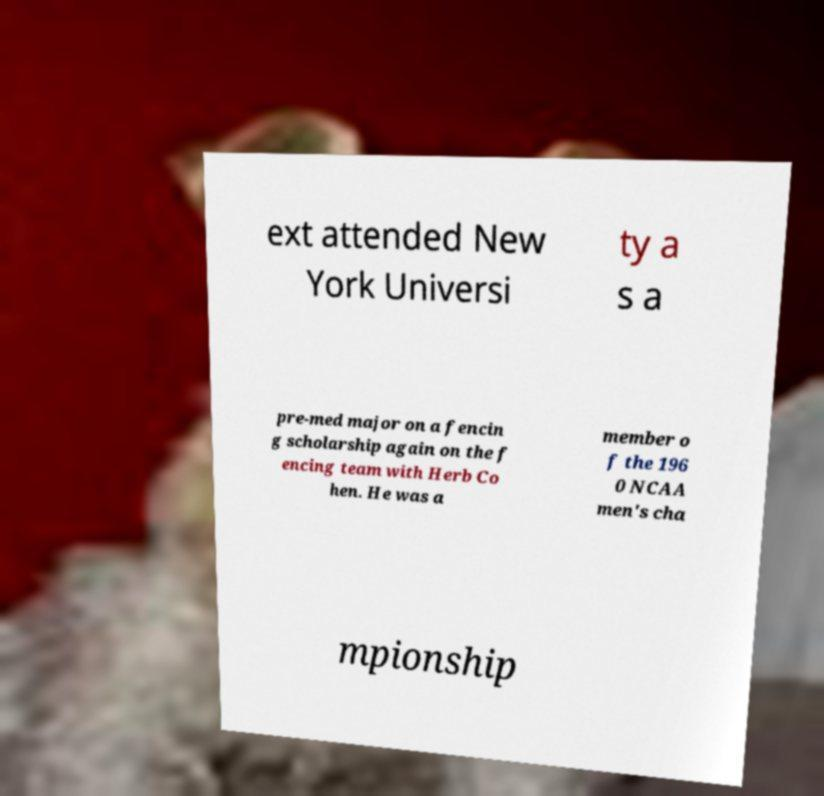Please identify and transcribe the text found in this image. ext attended New York Universi ty a s a pre-med major on a fencin g scholarship again on the f encing team with Herb Co hen. He was a member o f the 196 0 NCAA men's cha mpionship 